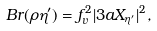Convert formula to latex. <formula><loc_0><loc_0><loc_500><loc_500>B r ( \rho \eta ^ { \prime } ) = f ^ { 2 } _ { v } | 3 a X _ { \eta ^ { \prime } } | ^ { 2 } ,</formula> 